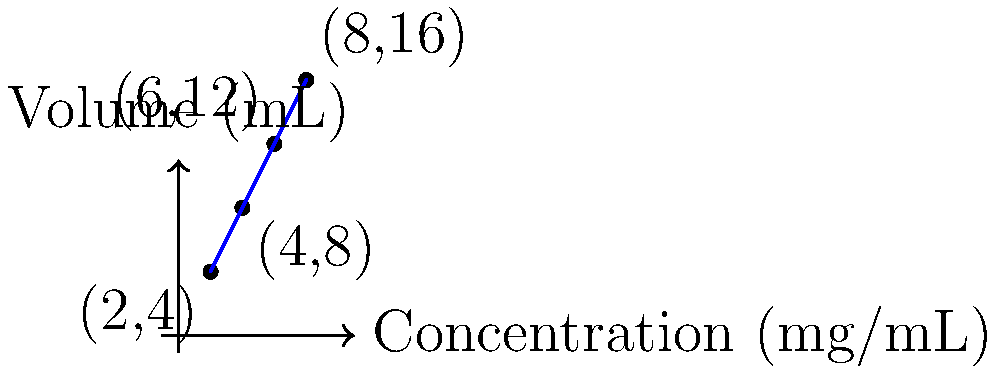As a pharmacist, you need to prepare a medication with a specific concentration. The chart shows the relationship between the concentration and volume of a drug solution. If you need to prepare 10 mL of this solution, what would be its concentration in mg/mL? To solve this problem, we'll use the concept of proportions. Let's follow these steps:

1. Observe the pattern in the graph:
   - (2 mL, 4 mg/mL)
   - (4 mL, 8 mg/mL)
   - (6 mL, 12 mg/mL)
   - (8 mL, 16 mg/mL)

2. We can see that as the volume doubles, the concentration doubles as well. This indicates a direct proportion.

3. Let's set up a proportion equation:
   $$\frac{\text{Volume}_1}{\text{Concentration}_1} = \frac{\text{Volume}_2}{\text{Concentration}_2}$$

4. We can use any point from the graph. Let's choose (2 mL, 4 mg/mL) and our target volume of 10 mL:
   $$\frac{2 \text{ mL}}{4 \text{ mg/mL}} = \frac{10 \text{ mL}}{x \text{ mg/mL}}$$

5. Cross multiply:
   $$2x = 10 \cdot 4$$

6. Solve for x:
   $$x = \frac{10 \cdot 4}{2} = 20$$

Therefore, the concentration for 10 mL of the solution would be 20 mg/mL.
Answer: 20 mg/mL 